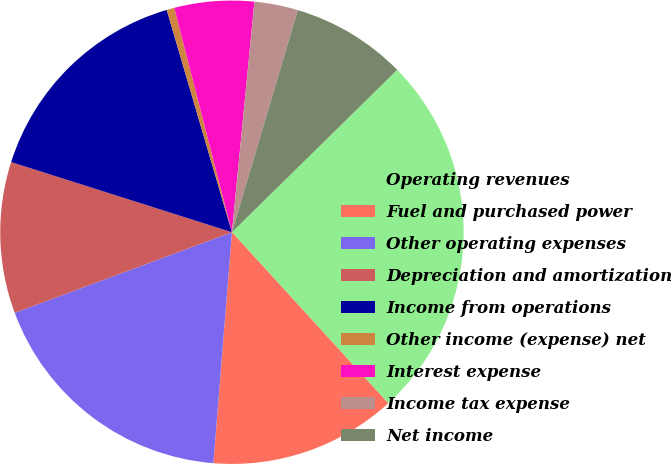Convert chart. <chart><loc_0><loc_0><loc_500><loc_500><pie_chart><fcel>Operating revenues<fcel>Fuel and purchased power<fcel>Other operating expenses<fcel>Depreciation and amortization<fcel>Income from operations<fcel>Other income (expense) net<fcel>Interest expense<fcel>Income tax expense<fcel>Net income<nl><fcel>25.58%<fcel>13.06%<fcel>18.07%<fcel>10.55%<fcel>15.56%<fcel>0.54%<fcel>5.55%<fcel>3.04%<fcel>8.05%<nl></chart> 